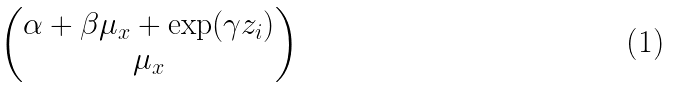<formula> <loc_0><loc_0><loc_500><loc_500>\begin{pmatrix} \alpha + \beta \mu _ { x } + \exp ( \gamma z _ { i } ) \\ \mu _ { x } \end{pmatrix}</formula> 